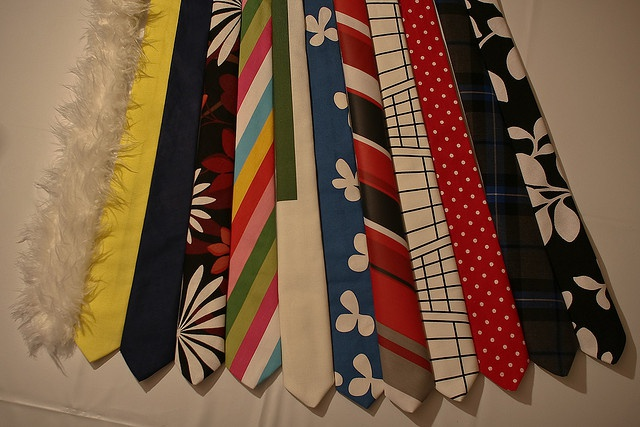Describe the objects in this image and their specific colors. I can see tie in gray, tan, black, and darkgreen tones, tie in gray, maroon, and black tones, tie in gray, maroon, brown, and tan tones, tie in gray, black, and maroon tones, and tie in gray, black, maroon, and olive tones in this image. 